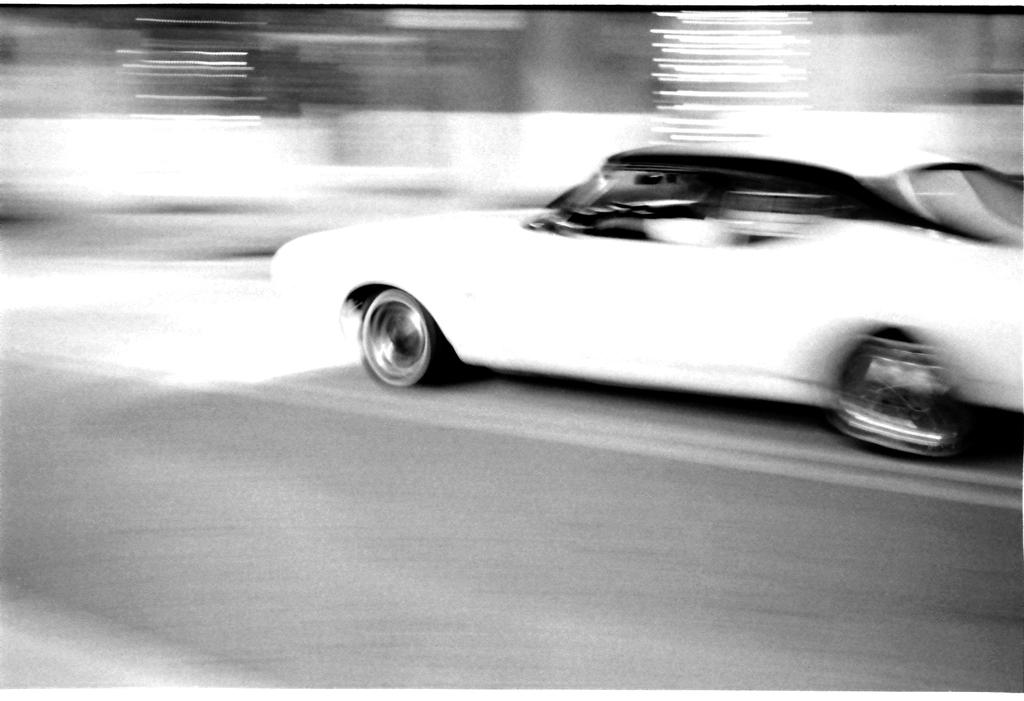What is the main subject of the image? The main subject of the image is a car. Where is the car located in the image? The car is on the road in the image. Can you describe the background of the image? The background of the image is blurry. How many boats are visible in the image? There are no boats present in the image; it features a car on the road. What type of mine is depicted in the image? There is no mine present in the image; it features a car on the road. 